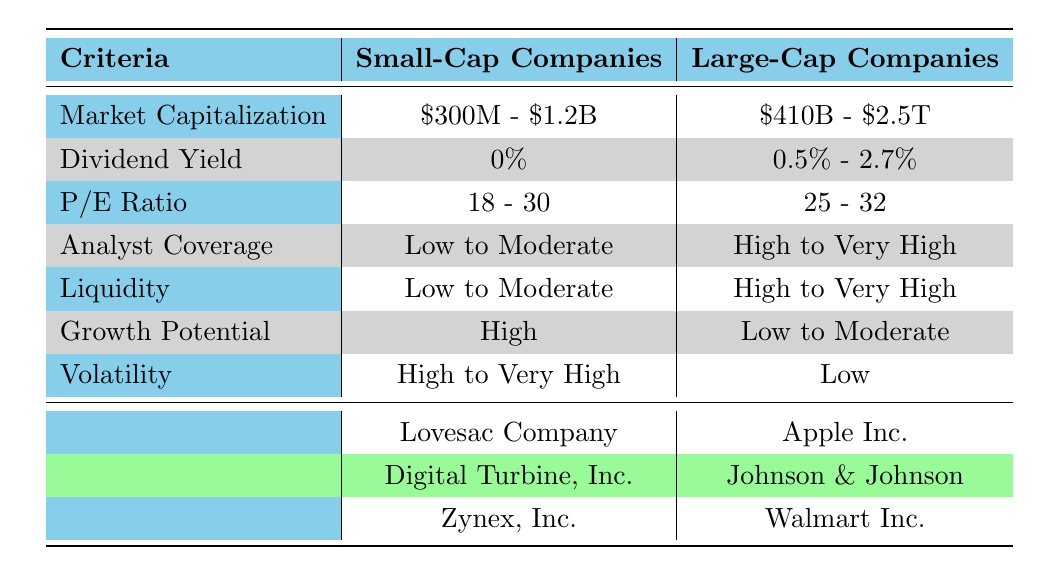What is the market capitalization range of small-cap companies? The table shows that small-cap companies have a market capitalization range from $300 million to $1.2 billion.
Answer: $300M - $1.2B Which company has the highest P/E ratio among the small-cap companies? Looking at the P/E ratio listed for each small-cap company, Digital Turbine, Inc. has the highest P/E ratio at 30.
Answer: Digital Turbine, Inc Is the volatility for large-cap companies low? According to the table, large-cap companies have low volatility, indicating that this statement is true.
Answer: Yes What is the average dividend yield for large-cap companies? The dividend yield for large-cap companies includes 0.5%, 2.7%, and 1.5%. Adding them gives 0.5 + 2.7 + 1.5 = 4.7, and dividing by 3 (the number of companies) gives an average of approximately 1.57%.
Answer: 1.57% Which type of companies has a higher growth potential, small-cap or large-cap? The table states that small-cap companies have high growth potential, while large-cap companies have low to moderate growth potential. Therefore, small-cap companies have a higher growth potential.
Answer: Small-cap companies Are there any small-cap companies with a dividend yield? All listed small-cap companies have a dividend yield of 0%, meaning they do not pay dividends. Therefore, this statement is false.
Answer: No What is the liquidity level for Zynex, Inc.? The table shows that Zynex, Inc. has low liquidity, making it the only small-cap company categorized this way.
Answer: Low Which company has the highest analyst coverage, and what is it? By scanning the analyst coverage column, Apple Inc. has the highest coverage rated as 'Very High,' which is the top classification given.
Answer: Apple Inc 